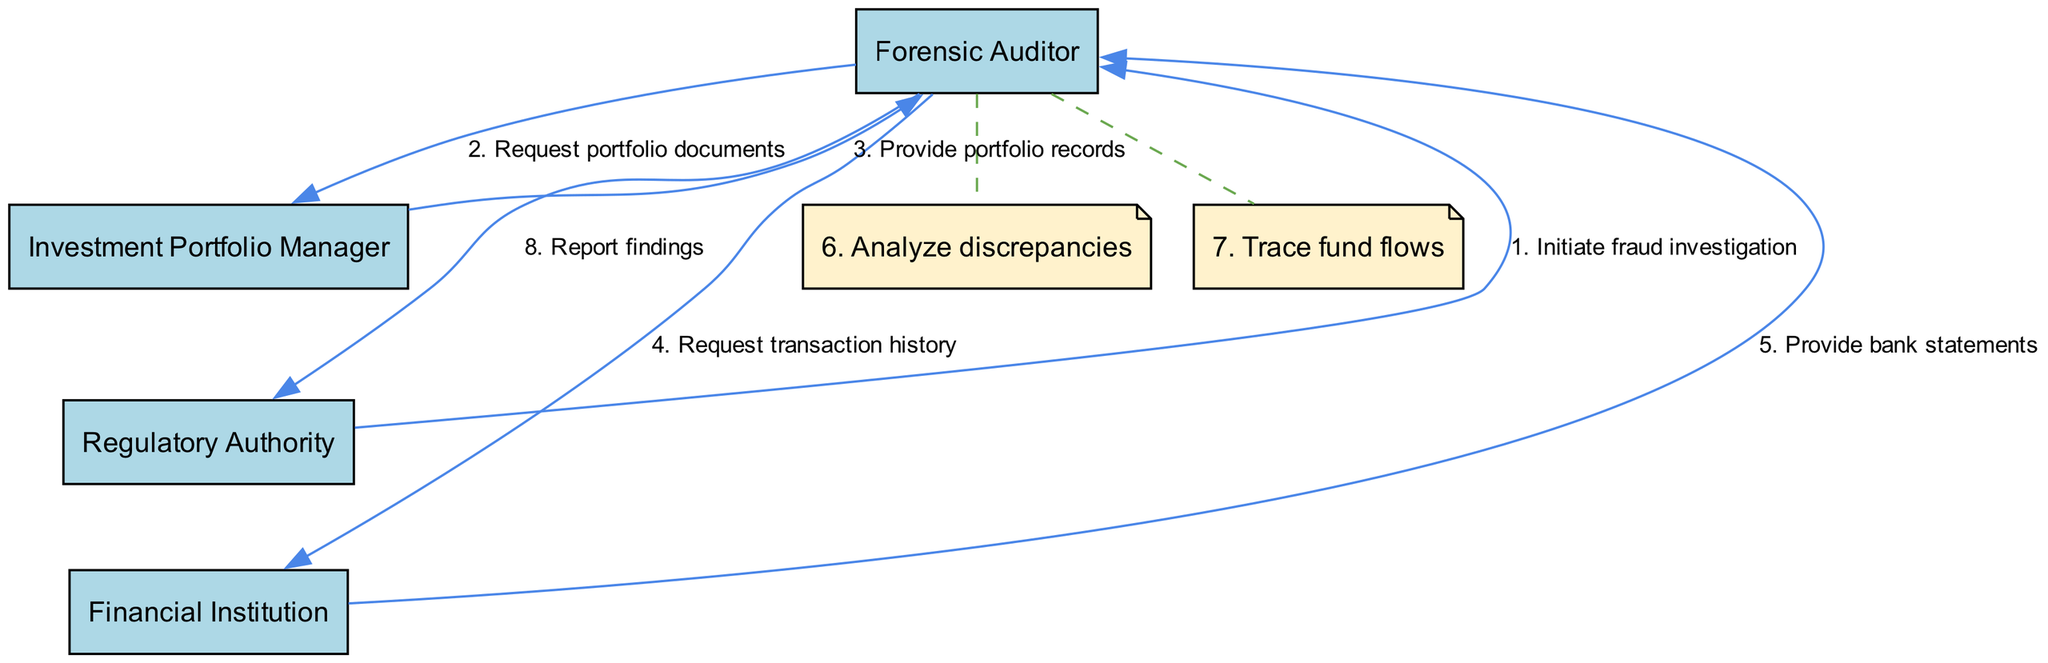What action does the Regulatory Authority take first? The first action in the sequence diagram is initiated by the Regulatory Authority, which invokes the "Initiate fraud investigation" step. This is the starting point of the sequence of interactions between the different actors.
Answer: Initiate fraud investigation How many steps are there in total? Counting the actions listed in the sequence, there are a total of eight distinct steps represented in the diagram. Each step corresponds to an action taken by the actors involved in the forensic audit process.
Answer: 8 Which actor provides bank statements to the Forensic Auditor? The Financial Institution is the actor that provides the bank statements, as indicated in the sequence where it responds to a request from the Forensic Auditor with this information.
Answer: Financial Institution What is the last action performed in the sequence? The last action in the sequence is a report of findings made by the Forensic Auditor to the Regulatory Authority, concluding the sequence of interactions.
Answer: Report findings Who requests portfolio documents from the Investment Portfolio Manager? The Forensic Auditor is the one who requests the portfolio documents, as per the sequence where it directly communicates with the Investment Portfolio Manager to obtain this information.
Answer: Forensic Auditor How many actors are involved in this sequence diagram? There are four actors involved in this diagram: Forensic Auditor, Investment Portfolio Manager, Regulatory Authority, and Financial Institution, as listed in the initial part of the diagram data.
Answer: 4 What does the Forensic Auditor analyze after receiving the bank statements? The Forensic Auditor performs an analysis of discrepancies after obtaining the bank statements, as indicated by the actions following the receipt of the financial data.
Answer: Analyze discrepancies Which step involves tracing fund flows? The step where the Forensic Auditor traces fund flows is directly after analyzing discrepancies, indicating a deeper examination of the financial data to follow the movements of funds.
Answer: Trace fund flows 